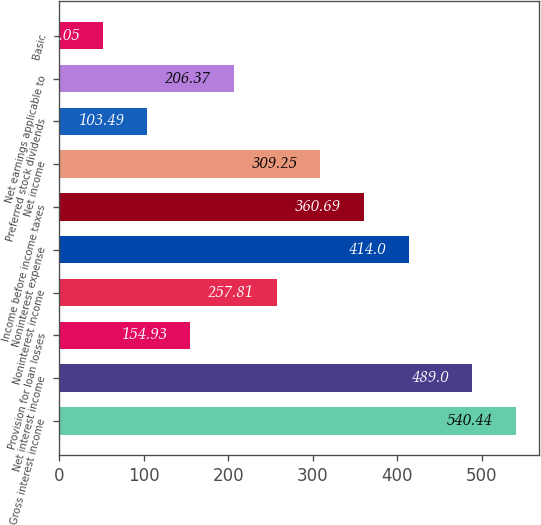Convert chart to OTSL. <chart><loc_0><loc_0><loc_500><loc_500><bar_chart><fcel>Gross interest income<fcel>Net interest income<fcel>Provision for loan losses<fcel>Noninterest income<fcel>Noninterest expense<fcel>Income before income taxes<fcel>Net income<fcel>Preferred stock dividends<fcel>Net earnings applicable to<fcel>Basic<nl><fcel>540.44<fcel>489<fcel>154.93<fcel>257.81<fcel>414<fcel>360.69<fcel>309.25<fcel>103.49<fcel>206.37<fcel>52.05<nl></chart> 